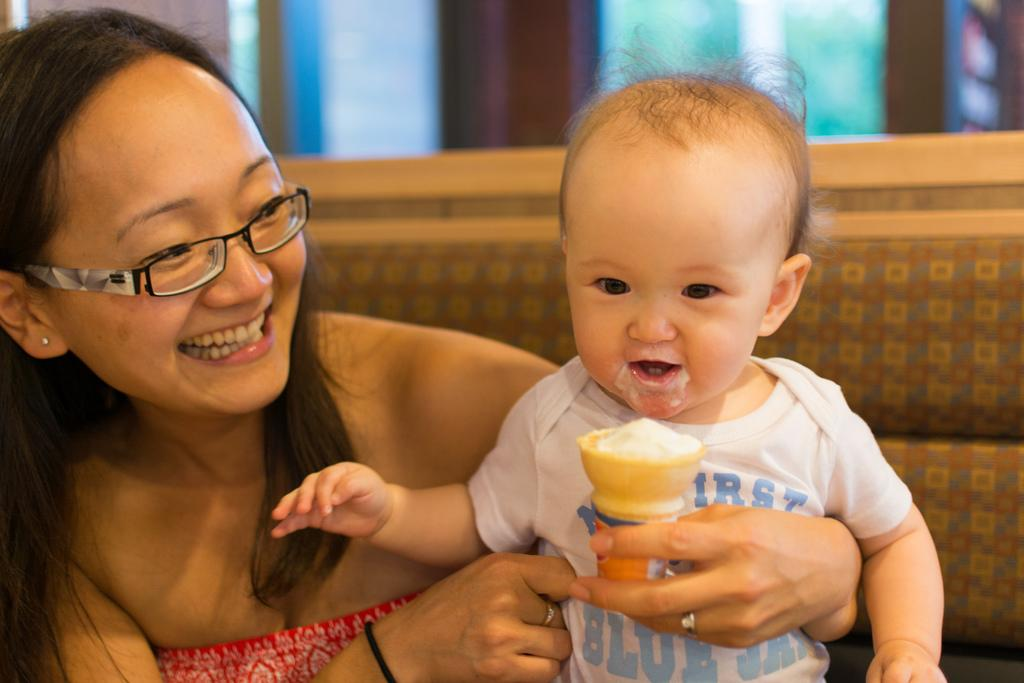Who is the main subject in the image? There is a woman in the image. What is the woman holding in her arms? The woman is holding a baby in her arms. What else is the woman holding in her hand? The woman is holding an ice cream cone in her hand. What can be seen on the woman's face? The woman is wearing spectacles. Where is the woman sitting in the image? The woman is sitting on a sofa. What is visible behind the sofa? There is a window behind the sofa. What grade does the beetle receive in the image? There is no beetle present in the image, so it cannot receive a grade. What type of amusement can be seen in the image? There is no amusement depicted in the image; it features a woman holding a baby and an ice cream cone while sitting on a sofa. 